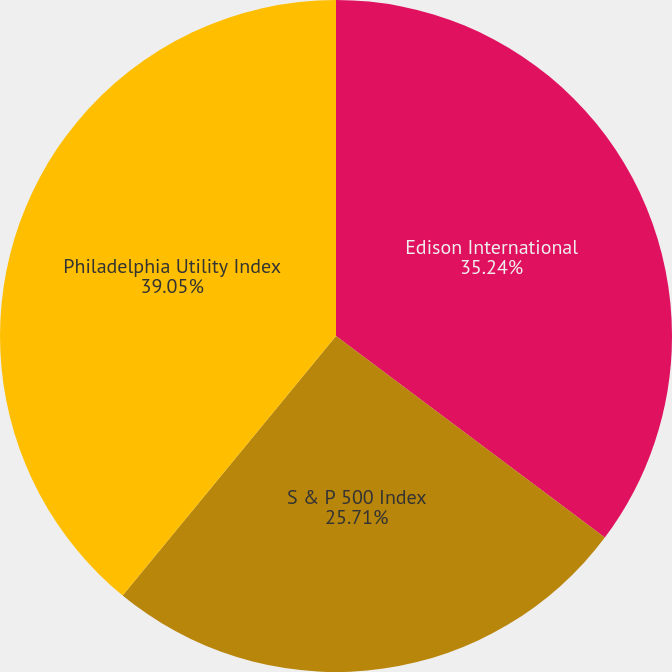Convert chart to OTSL. <chart><loc_0><loc_0><loc_500><loc_500><pie_chart><fcel>Edison International<fcel>S & P 500 Index<fcel>Philadelphia Utility Index<nl><fcel>35.24%<fcel>25.71%<fcel>39.05%<nl></chart> 